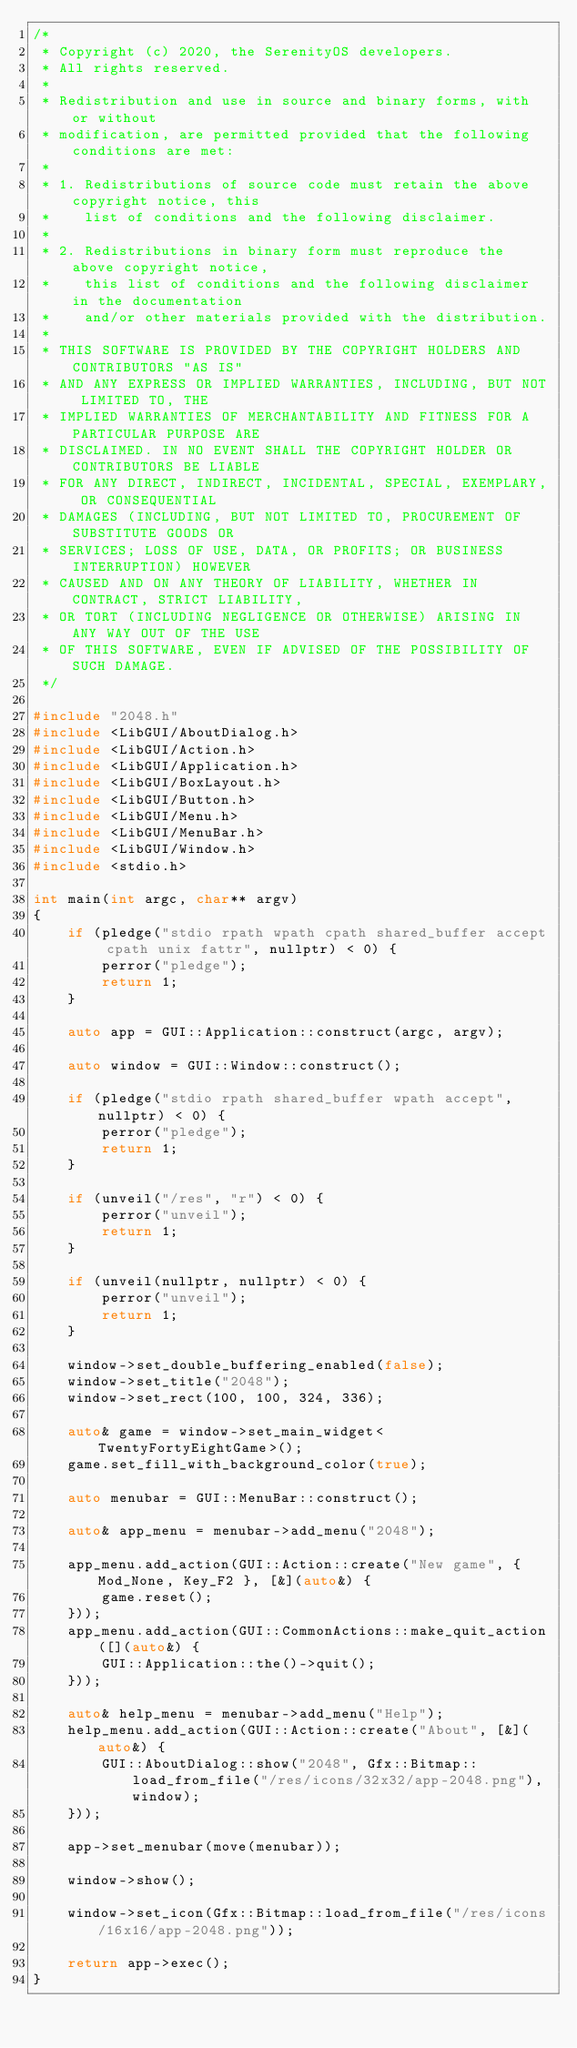Convert code to text. <code><loc_0><loc_0><loc_500><loc_500><_C++_>/*
 * Copyright (c) 2020, the SerenityOS developers.
 * All rights reserved.
 *
 * Redistribution and use in source and binary forms, with or without
 * modification, are permitted provided that the following conditions are met:
 *
 * 1. Redistributions of source code must retain the above copyright notice, this
 *    list of conditions and the following disclaimer.
 *
 * 2. Redistributions in binary form must reproduce the above copyright notice,
 *    this list of conditions and the following disclaimer in the documentation
 *    and/or other materials provided with the distribution.
 *
 * THIS SOFTWARE IS PROVIDED BY THE COPYRIGHT HOLDERS AND CONTRIBUTORS "AS IS"
 * AND ANY EXPRESS OR IMPLIED WARRANTIES, INCLUDING, BUT NOT LIMITED TO, THE
 * IMPLIED WARRANTIES OF MERCHANTABILITY AND FITNESS FOR A PARTICULAR PURPOSE ARE
 * DISCLAIMED. IN NO EVENT SHALL THE COPYRIGHT HOLDER OR CONTRIBUTORS BE LIABLE
 * FOR ANY DIRECT, INDIRECT, INCIDENTAL, SPECIAL, EXEMPLARY, OR CONSEQUENTIAL
 * DAMAGES (INCLUDING, BUT NOT LIMITED TO, PROCUREMENT OF SUBSTITUTE GOODS OR
 * SERVICES; LOSS OF USE, DATA, OR PROFITS; OR BUSINESS INTERRUPTION) HOWEVER
 * CAUSED AND ON ANY THEORY OF LIABILITY, WHETHER IN CONTRACT, STRICT LIABILITY,
 * OR TORT (INCLUDING NEGLIGENCE OR OTHERWISE) ARISING IN ANY WAY OUT OF THE USE
 * OF THIS SOFTWARE, EVEN IF ADVISED OF THE POSSIBILITY OF SUCH DAMAGE.
 */

#include "2048.h"
#include <LibGUI/AboutDialog.h>
#include <LibGUI/Action.h>
#include <LibGUI/Application.h>
#include <LibGUI/BoxLayout.h>
#include <LibGUI/Button.h>
#include <LibGUI/Menu.h>
#include <LibGUI/MenuBar.h>
#include <LibGUI/Window.h>
#include <stdio.h>

int main(int argc, char** argv)
{
    if (pledge("stdio rpath wpath cpath shared_buffer accept cpath unix fattr", nullptr) < 0) {
        perror("pledge");
        return 1;
    }

    auto app = GUI::Application::construct(argc, argv);

    auto window = GUI::Window::construct();

    if (pledge("stdio rpath shared_buffer wpath accept", nullptr) < 0) {
        perror("pledge");
        return 1;
    }

    if (unveil("/res", "r") < 0) {
        perror("unveil");
        return 1;
    }

    if (unveil(nullptr, nullptr) < 0) {
        perror("unveil");
        return 1;
    }

    window->set_double_buffering_enabled(false);
    window->set_title("2048");
    window->set_rect(100, 100, 324, 336);

    auto& game = window->set_main_widget<TwentyFortyEightGame>();
    game.set_fill_with_background_color(true);

    auto menubar = GUI::MenuBar::construct();

    auto& app_menu = menubar->add_menu("2048");

    app_menu.add_action(GUI::Action::create("New game", { Mod_None, Key_F2 }, [&](auto&) {
        game.reset();
    }));
    app_menu.add_action(GUI::CommonActions::make_quit_action([](auto&) {
        GUI::Application::the()->quit();
    }));

    auto& help_menu = menubar->add_menu("Help");
    help_menu.add_action(GUI::Action::create("About", [&](auto&) {
        GUI::AboutDialog::show("2048", Gfx::Bitmap::load_from_file("/res/icons/32x32/app-2048.png"), window);
    }));

    app->set_menubar(move(menubar));

    window->show();

    window->set_icon(Gfx::Bitmap::load_from_file("/res/icons/16x16/app-2048.png"));

    return app->exec();
}
</code> 